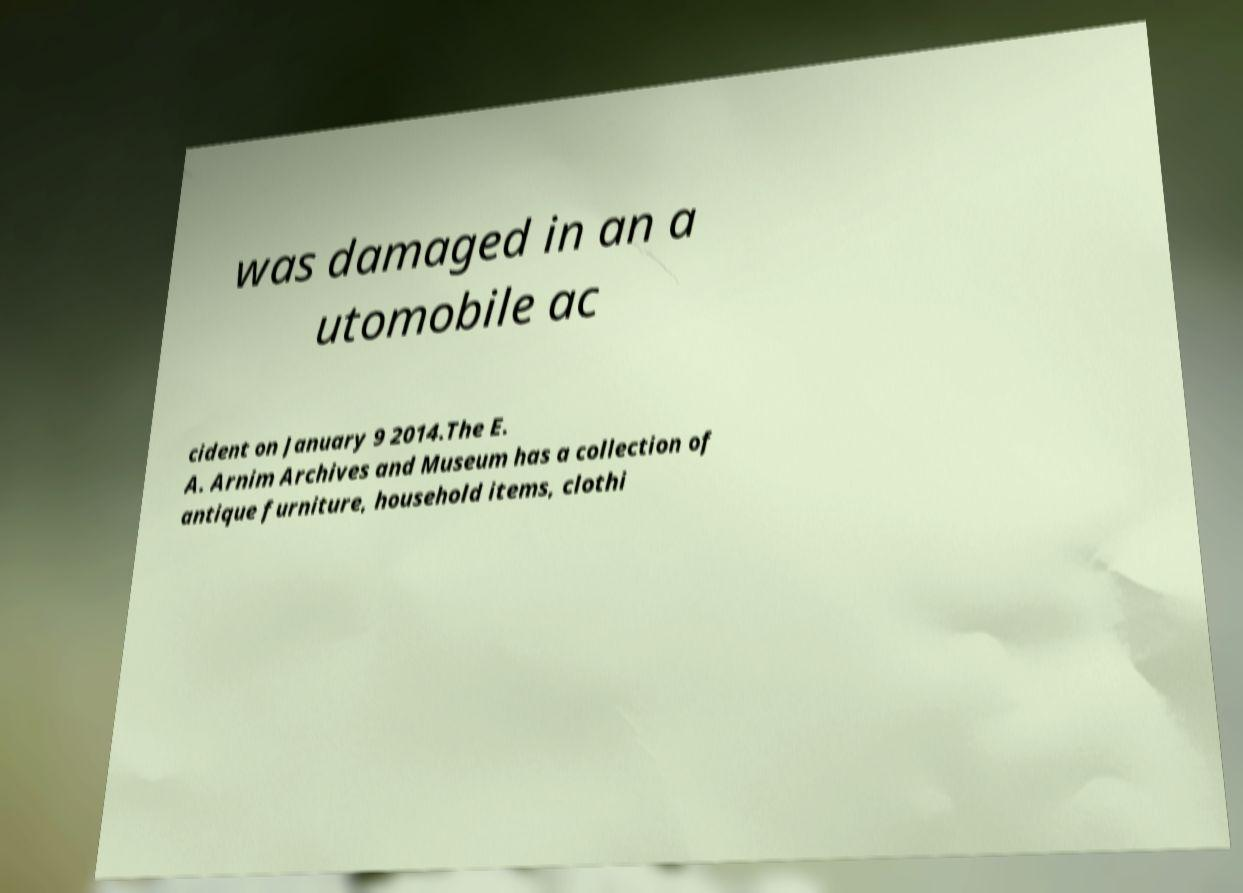For documentation purposes, I need the text within this image transcribed. Could you provide that? was damaged in an a utomobile ac cident on January 9 2014.The E. A. Arnim Archives and Museum has a collection of antique furniture, household items, clothi 